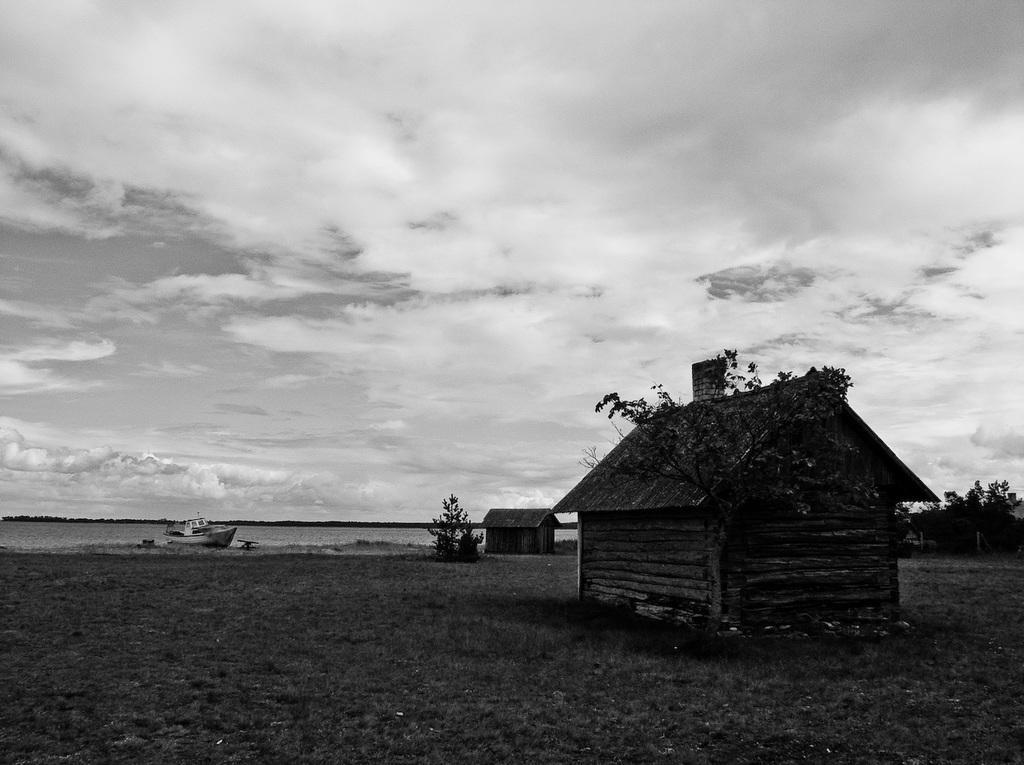Please provide a concise description of this image. In this picture there is a boat here, there is ocean and there are some buildings and the sky is clear. 